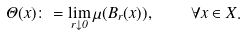Convert formula to latex. <formula><loc_0><loc_0><loc_500><loc_500>\Theta ( x ) \colon = \lim _ { r \downarrow 0 } \mu ( B _ { r } ( x ) ) , \quad \forall x \in X .</formula> 